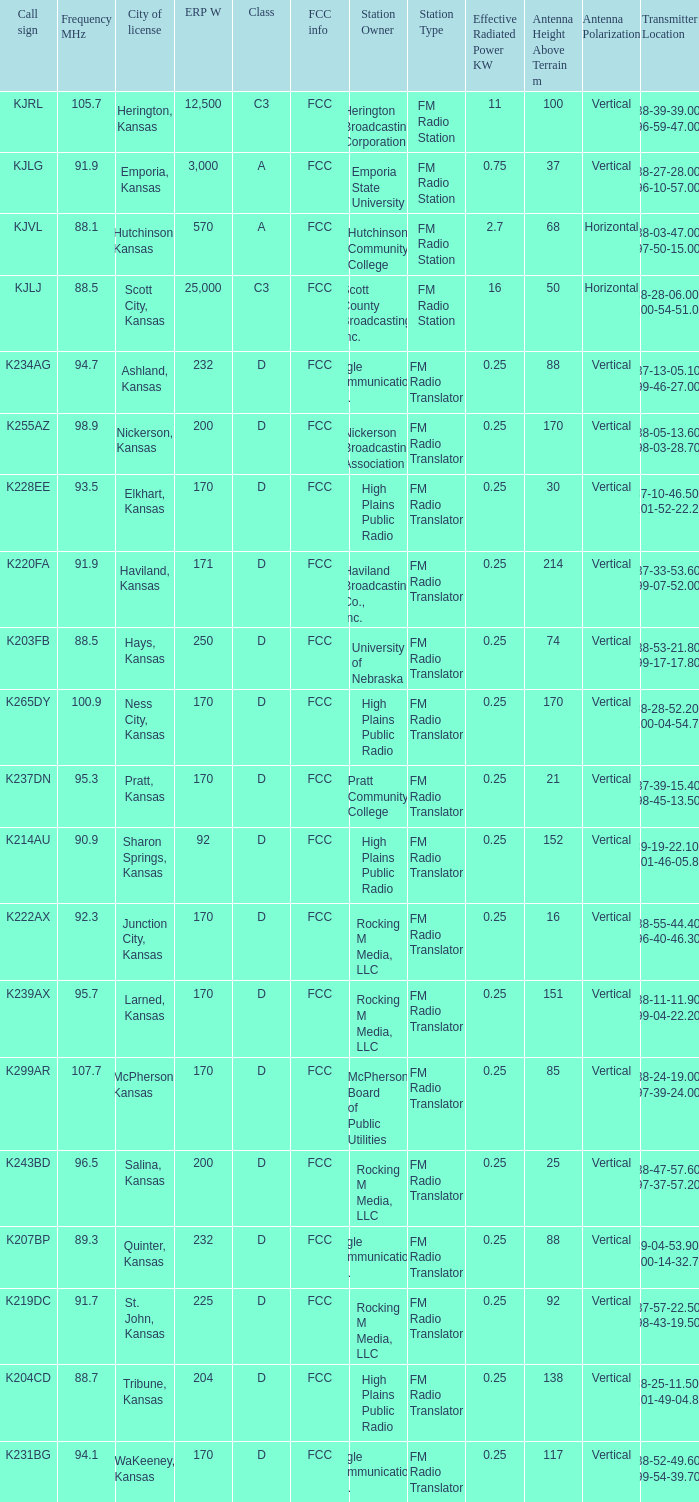ERP W that has a Class of d, and a Call sign of k299ar is what total number? 1.0. 